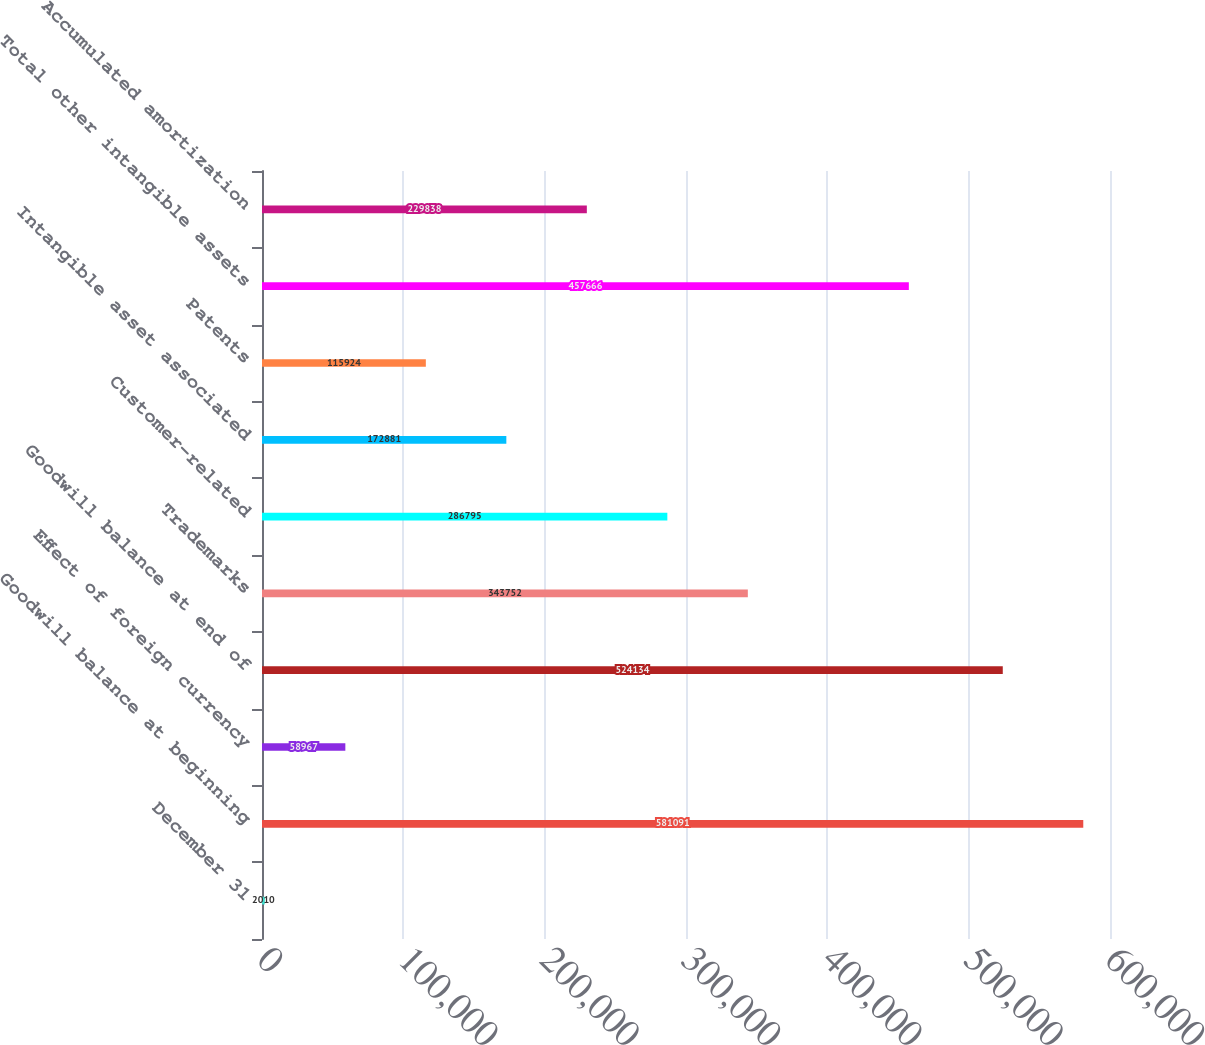<chart> <loc_0><loc_0><loc_500><loc_500><bar_chart><fcel>December 31<fcel>Goodwill balance at beginning<fcel>Effect of foreign currency<fcel>Goodwill balance at end of<fcel>Trademarks<fcel>Customer-related<fcel>Intangible asset associated<fcel>Patents<fcel>Total other intangible assets<fcel>Accumulated amortization<nl><fcel>2010<fcel>581091<fcel>58967<fcel>524134<fcel>343752<fcel>286795<fcel>172881<fcel>115924<fcel>457666<fcel>229838<nl></chart> 